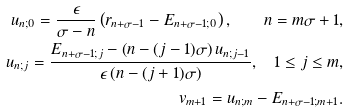<formula> <loc_0><loc_0><loc_500><loc_500>u _ { n ; 0 } = \frac { \epsilon } { \sigma - n } \left ( r _ { n + \sigma - 1 } - E _ { n + \sigma - 1 ; 0 } \right ) , \quad n = m \sigma + 1 , \\ u _ { n ; j } = \frac { E _ { n + \sigma - 1 ; j } - \left ( n - ( j - 1 ) \sigma \right ) u _ { n ; j - 1 } } { \epsilon \left ( n - ( j + 1 ) \sigma \right ) } , \quad 1 \leq j \leq m , \\ v _ { m + 1 } = u _ { n ; m } - E _ { n + \sigma - 1 ; m + 1 } .</formula> 